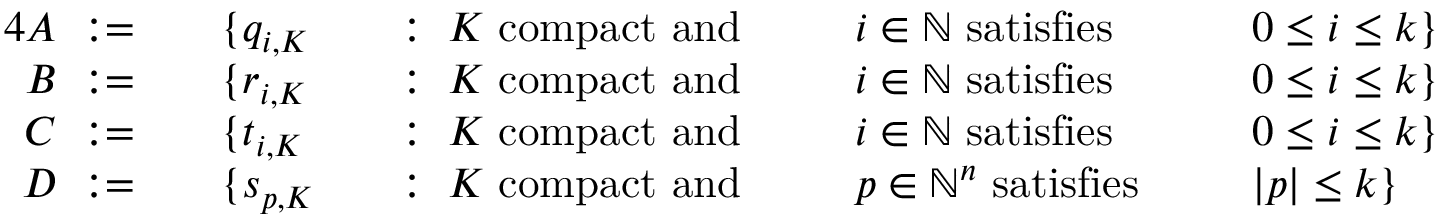<formula> <loc_0><loc_0><loc_500><loc_500>{ \begin{array} { r l r l r l r l } { { 4 } A \colon = \quad } & { \{ q _ { i , K } } & & { \colon \, K { c o m p a c t a n d } \, } & & { i \in \mathbb { N } { s a t i s f i e s } \, } & & { 0 \leq i \leq k \} } \\ { B \colon = \quad } & { \{ r _ { i , K } } & & { \colon \, K { c o m p a c t a n d } \, } & & { i \in \mathbb { N } { s a t i s f i e s } \, } & & { 0 \leq i \leq k \} } \\ { C \colon = \quad } & { \{ t _ { i , K } } & & { \colon \, K { c o m p a c t a n d } \, } & & { i \in \mathbb { N } { s a t i s f i e s } \, } & & { 0 \leq i \leq k \} } \\ { D \colon = \quad } & { \{ s _ { p , K } } & & { \colon \, K { c o m p a c t a n d } \, } & & { p \in \mathbb { N } ^ { n } { s a t i s f i e s } \, } & & { | p | \leq k \} } \end{array} }</formula> 